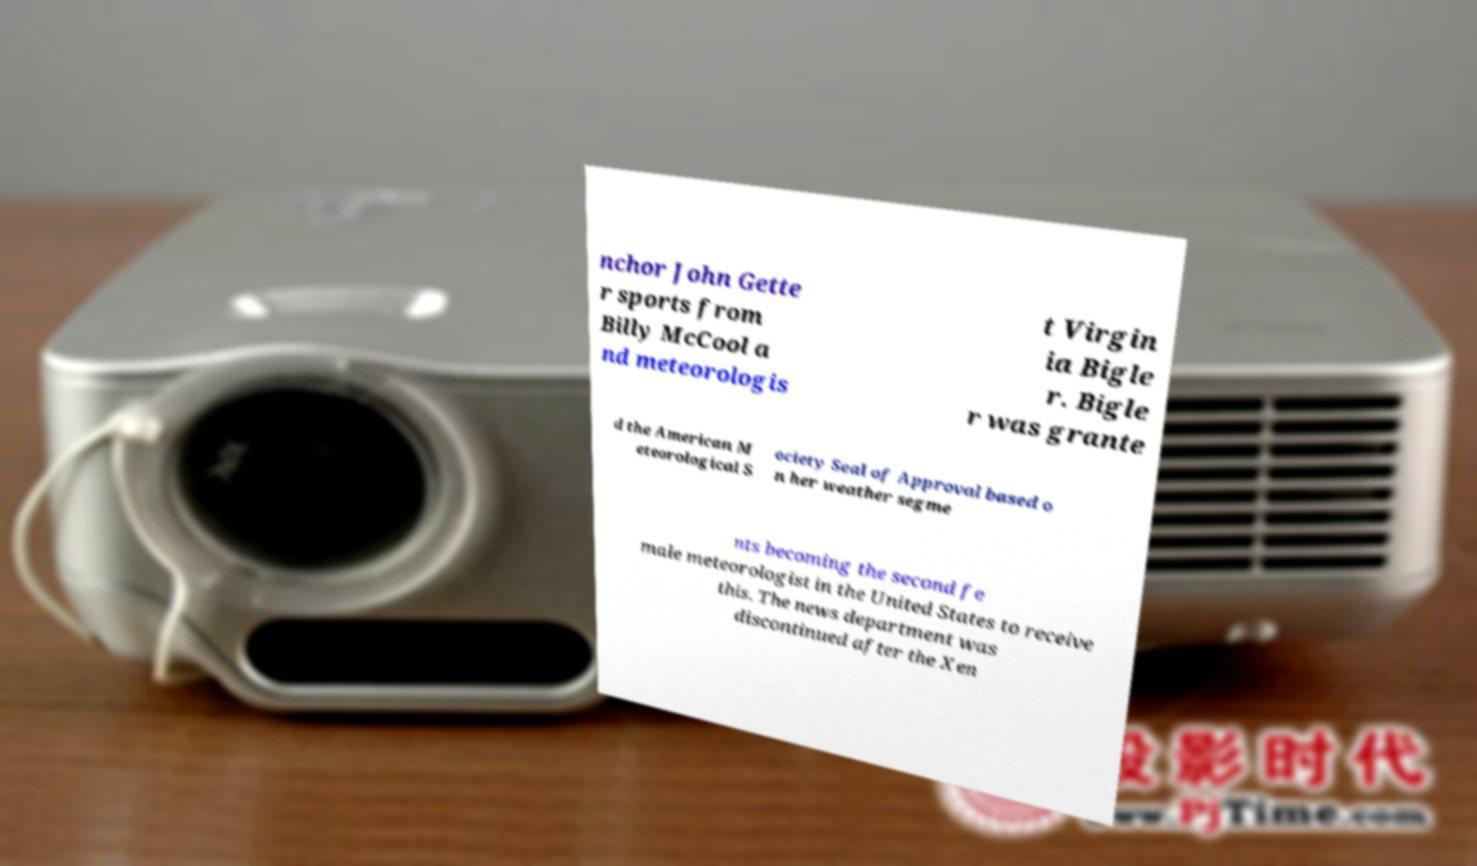Can you read and provide the text displayed in the image?This photo seems to have some interesting text. Can you extract and type it out for me? nchor John Gette r sports from Billy McCool a nd meteorologis t Virgin ia Bigle r. Bigle r was grante d the American M eteorological S ociety Seal of Approval based o n her weather segme nts becoming the second fe male meteorologist in the United States to receive this. The news department was discontinued after the Xen 